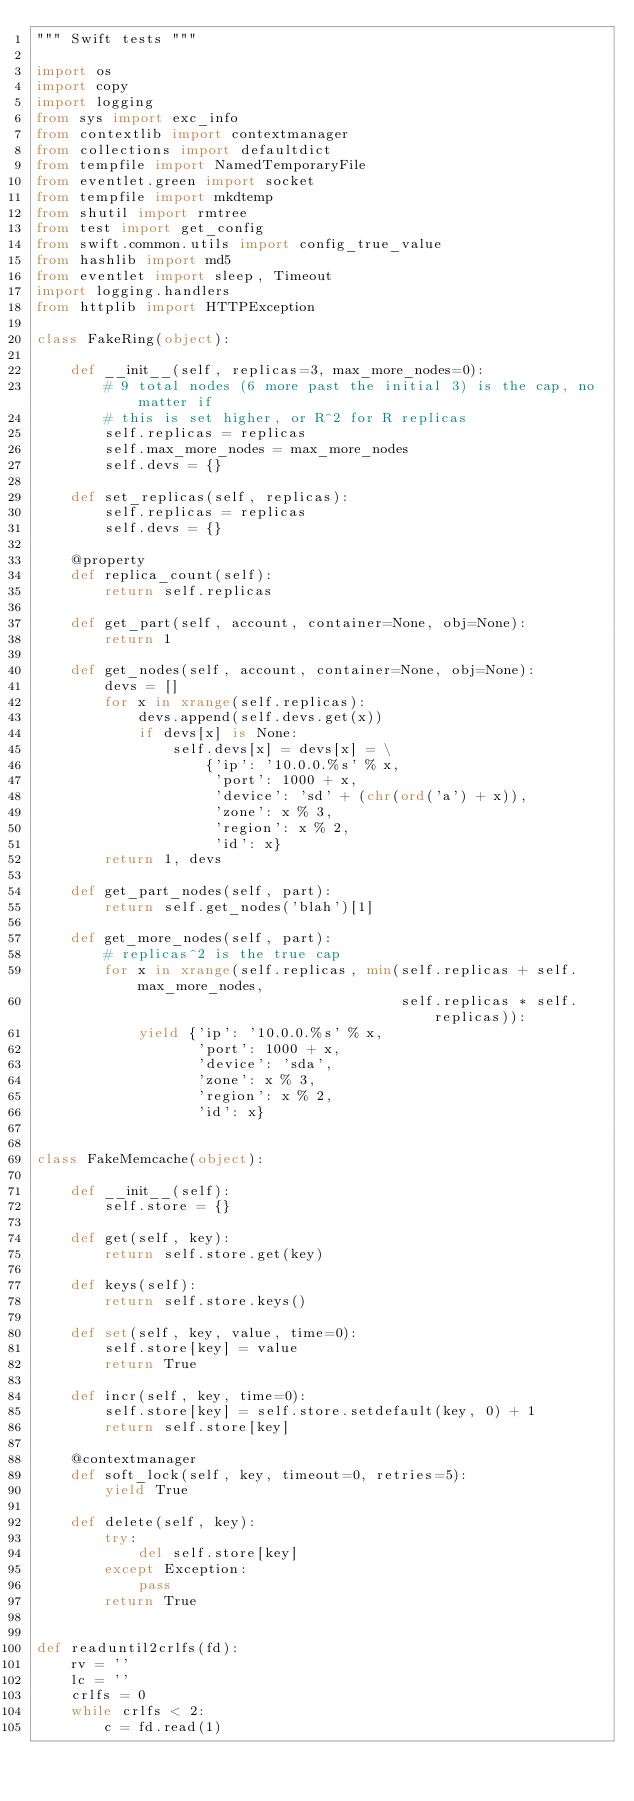Convert code to text. <code><loc_0><loc_0><loc_500><loc_500><_Python_>""" Swift tests """

import os
import copy
import logging
from sys import exc_info
from contextlib import contextmanager
from collections import defaultdict
from tempfile import NamedTemporaryFile
from eventlet.green import socket
from tempfile import mkdtemp
from shutil import rmtree
from test import get_config
from swift.common.utils import config_true_value
from hashlib import md5
from eventlet import sleep, Timeout
import logging.handlers
from httplib import HTTPException

class FakeRing(object):

    def __init__(self, replicas=3, max_more_nodes=0):
        # 9 total nodes (6 more past the initial 3) is the cap, no matter if
        # this is set higher, or R^2 for R replicas
        self.replicas = replicas
        self.max_more_nodes = max_more_nodes
        self.devs = {}

    def set_replicas(self, replicas):
        self.replicas = replicas
        self.devs = {}

    @property
    def replica_count(self):
        return self.replicas

    def get_part(self, account, container=None, obj=None):
        return 1

    def get_nodes(self, account, container=None, obj=None):
        devs = []
        for x in xrange(self.replicas):
            devs.append(self.devs.get(x))
            if devs[x] is None:
                self.devs[x] = devs[x] = \
                    {'ip': '10.0.0.%s' % x,
                     'port': 1000 + x,
                     'device': 'sd' + (chr(ord('a') + x)),
                     'zone': x % 3,
                     'region': x % 2,
                     'id': x}
        return 1, devs

    def get_part_nodes(self, part):
        return self.get_nodes('blah')[1]

    def get_more_nodes(self, part):
        # replicas^2 is the true cap
        for x in xrange(self.replicas, min(self.replicas + self.max_more_nodes,
                                           self.replicas * self.replicas)):
            yield {'ip': '10.0.0.%s' % x,
                   'port': 1000 + x,
                   'device': 'sda',
                   'zone': x % 3,
                   'region': x % 2,
                   'id': x}


class FakeMemcache(object):

    def __init__(self):
        self.store = {}

    def get(self, key):
        return self.store.get(key)

    def keys(self):
        return self.store.keys()

    def set(self, key, value, time=0):
        self.store[key] = value
        return True

    def incr(self, key, time=0):
        self.store[key] = self.store.setdefault(key, 0) + 1
        return self.store[key]

    @contextmanager
    def soft_lock(self, key, timeout=0, retries=5):
        yield True

    def delete(self, key):
        try:
            del self.store[key]
        except Exception:
            pass
        return True


def readuntil2crlfs(fd):
    rv = ''
    lc = ''
    crlfs = 0
    while crlfs < 2:
        c = fd.read(1)</code> 